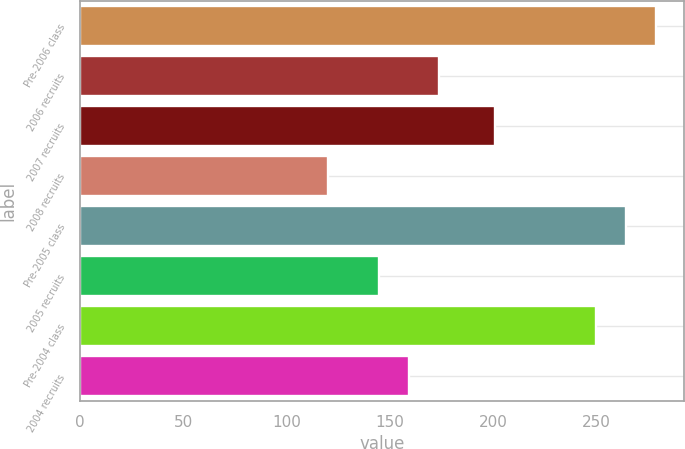Convert chart to OTSL. <chart><loc_0><loc_0><loc_500><loc_500><bar_chart><fcel>Pre-2006 class<fcel>2006 recruits<fcel>2007 recruits<fcel>2008 recruits<fcel>Pre-2005 class<fcel>2005 recruits<fcel>Pre-2004 class<fcel>2004 recruits<nl><fcel>278.8<fcel>173.8<fcel>201<fcel>120<fcel>264.4<fcel>145<fcel>250<fcel>159.4<nl></chart> 